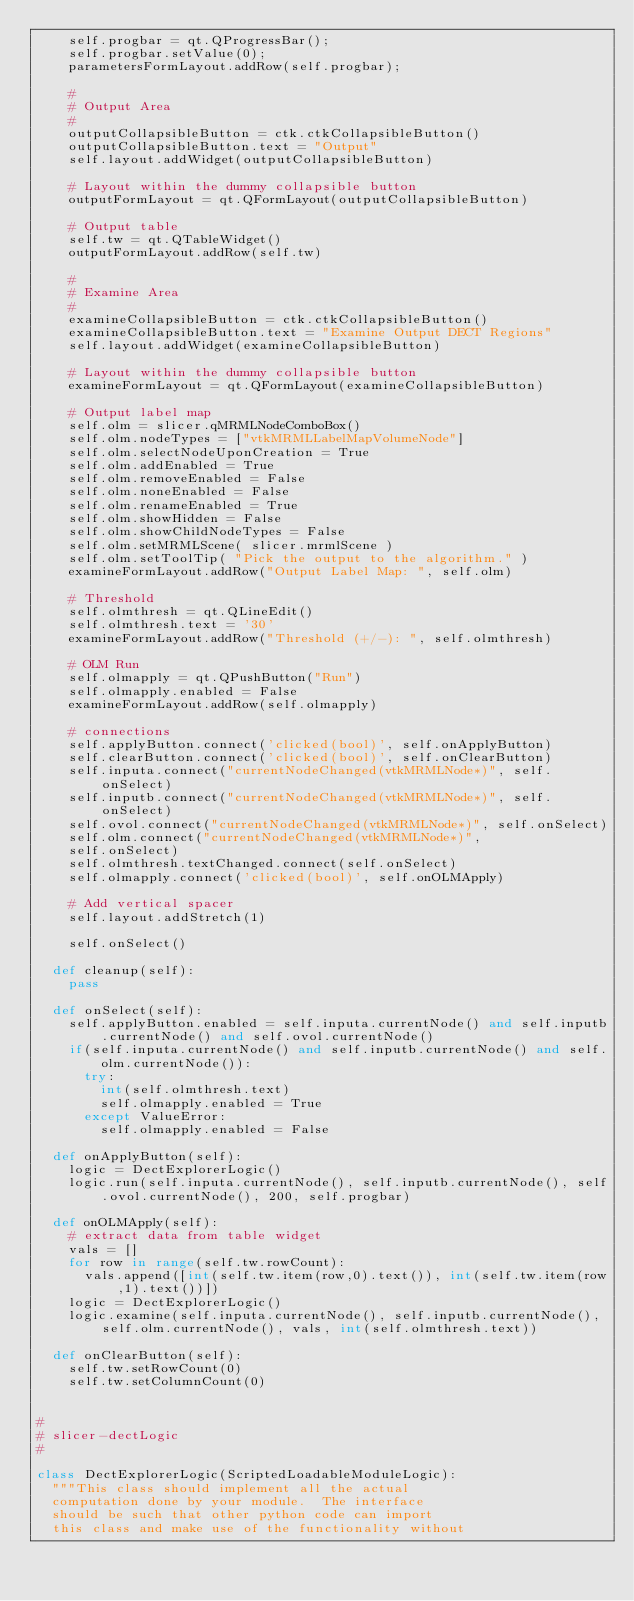Convert code to text. <code><loc_0><loc_0><loc_500><loc_500><_Python_>    self.progbar = qt.QProgressBar();
    self.progbar.setValue(0);
    parametersFormLayout.addRow(self.progbar);
    
    #
    # Output Area
    #
    outputCollapsibleButton = ctk.ctkCollapsibleButton()
    outputCollapsibleButton.text = "Output"
    self.layout.addWidget(outputCollapsibleButton)

    # Layout within the dummy collapsible button
    outputFormLayout = qt.QFormLayout(outputCollapsibleButton)
    
    # Output table
    self.tw = qt.QTableWidget()
    outputFormLayout.addRow(self.tw)
    
    #
    # Examine Area
    #
    examineCollapsibleButton = ctk.ctkCollapsibleButton()
    examineCollapsibleButton.text = "Examine Output DECT Regions"
    self.layout.addWidget(examineCollapsibleButton)

    # Layout within the dummy collapsible button
    examineFormLayout = qt.QFormLayout(examineCollapsibleButton)
    
    # Output label map
    self.olm = slicer.qMRMLNodeComboBox()
    self.olm.nodeTypes = ["vtkMRMLLabelMapVolumeNode"]
    self.olm.selectNodeUponCreation = True
    self.olm.addEnabled = True
    self.olm.removeEnabled = False
    self.olm.noneEnabled = False
    self.olm.renameEnabled = True
    self.olm.showHidden = False
    self.olm.showChildNodeTypes = False
    self.olm.setMRMLScene( slicer.mrmlScene )
    self.olm.setToolTip( "Pick the output to the algorithm." )
    examineFormLayout.addRow("Output Label Map: ", self.olm)

    # Threshold
    self.olmthresh = qt.QLineEdit()
    self.olmthresh.text = '30'
    examineFormLayout.addRow("Threshold (+/-): ", self.olmthresh)
    
    # OLM Run
    self.olmapply = qt.QPushButton("Run")
    self.olmapply.enabled = False
    examineFormLayout.addRow(self.olmapply)

    # connections
    self.applyButton.connect('clicked(bool)', self.onApplyButton)
    self.clearButton.connect('clicked(bool)', self.onClearButton)
    self.inputa.connect("currentNodeChanged(vtkMRMLNode*)", self.onSelect)
    self.inputb.connect("currentNodeChanged(vtkMRMLNode*)", self.onSelect)
    self.ovol.connect("currentNodeChanged(vtkMRMLNode*)", self.onSelect)
    self.olm.connect("currentNodeChanged(vtkMRMLNode*)",
    self.onSelect)
    self.olmthresh.textChanged.connect(self.onSelect)
    self.olmapply.connect('clicked(bool)', self.onOLMApply)
   
    # Add vertical spacer
    self.layout.addStretch(1)
    
    self.onSelect()

  def cleanup(self):
    pass
    
  def onSelect(self):
    self.applyButton.enabled = self.inputa.currentNode() and self.inputb.currentNode() and self.ovol.currentNode()
    if(self.inputa.currentNode() and self.inputb.currentNode() and self.olm.currentNode()):
      try:
        int(self.olmthresh.text)
        self.olmapply.enabled = True
      except ValueError:
        self.olmapply.enabled = False

  def onApplyButton(self):
    logic = DectExplorerLogic()
    logic.run(self.inputa.currentNode(), self.inputb.currentNode(), self.ovol.currentNode(), 200, self.progbar)
    
  def onOLMApply(self):
    # extract data from table widget
    vals = []
    for row in range(self.tw.rowCount):
      vals.append([int(self.tw.item(row,0).text()), int(self.tw.item(row,1).text())])
    logic = DectExplorerLogic()
    logic.examine(self.inputa.currentNode(), self.inputb.currentNode(), self.olm.currentNode(), vals, int(self.olmthresh.text))
    
  def onClearButton(self):
    self.tw.setRowCount(0)
    self.tw.setColumnCount(0)


#
# slicer-dectLogic
#

class DectExplorerLogic(ScriptedLoadableModuleLogic):
  """This class should implement all the actual
  computation done by your module.  The interface
  should be such that other python code can import
  this class and make use of the functionality without</code> 